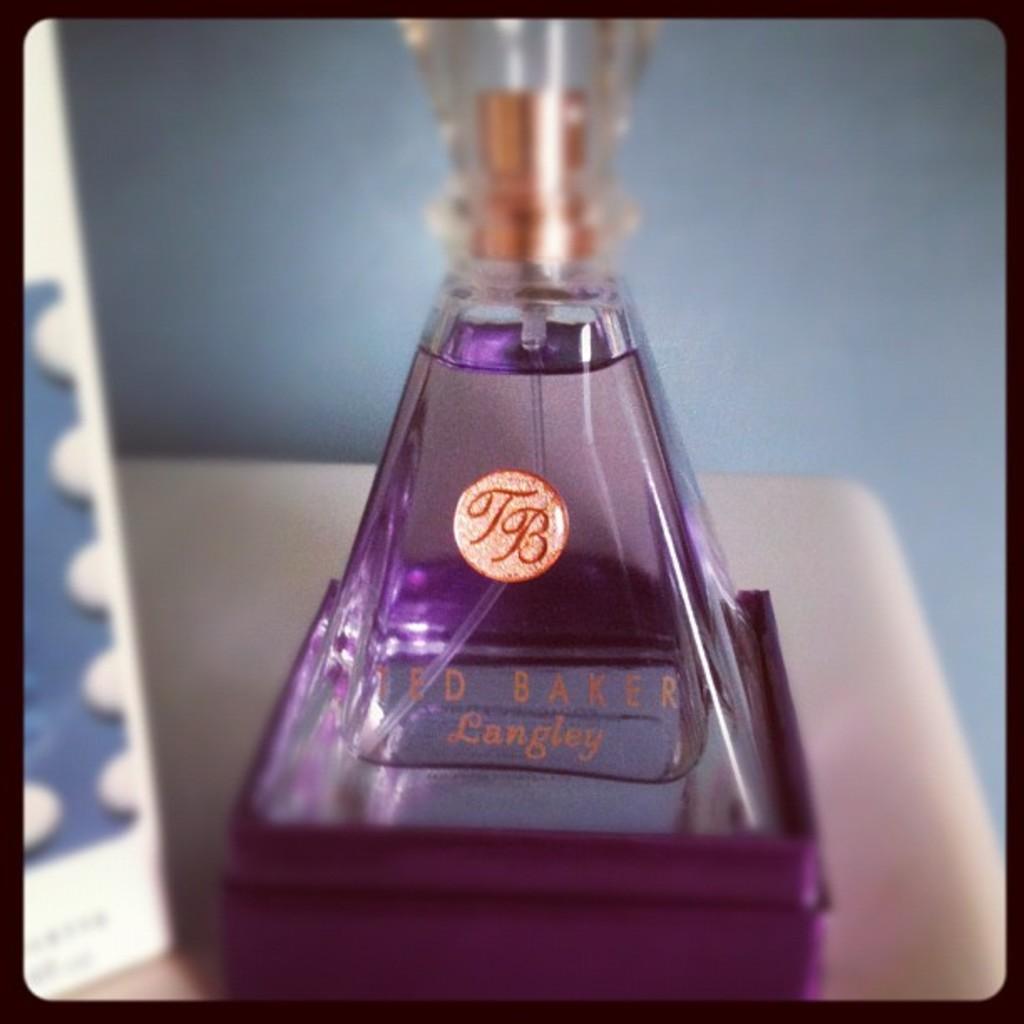What are the initials?
Give a very brief answer. Tb. 